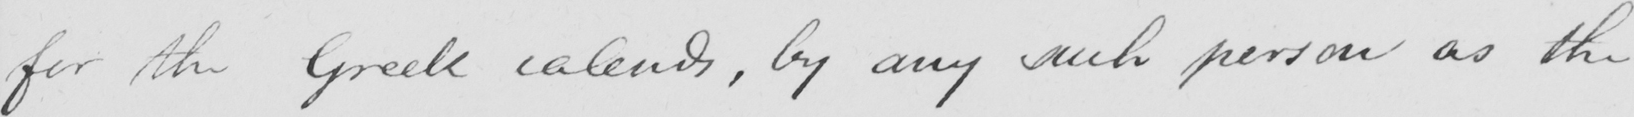What text is written in this handwritten line? for the Greek calends , by any such person as the 